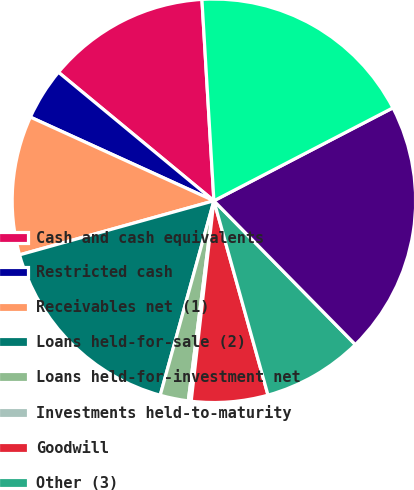Convert chart to OTSL. <chart><loc_0><loc_0><loc_500><loc_500><pie_chart><fcel>Cash and cash equivalents<fcel>Restricted cash<fcel>Receivables net (1)<fcel>Loans held-for-sale (2)<fcel>Loans held-for-investment net<fcel>Investments held-to-maturity<fcel>Goodwill<fcel>Other (3)<fcel>Notes and other debts payable<fcel>Other (4)<nl><fcel>13.06%<fcel>4.19%<fcel>11.13%<fcel>16.4%<fcel>2.26%<fcel>0.23%<fcel>6.12%<fcel>8.05%<fcel>20.26%<fcel>18.33%<nl></chart> 